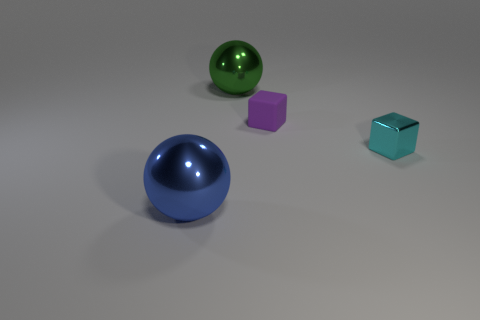Add 3 tiny gray blocks. How many objects exist? 7 Subtract all blue spheres. How many spheres are left? 1 Subtract all yellow cylinders. How many green balls are left? 1 Subtract 1 balls. How many balls are left? 1 Subtract all purple balls. Subtract all brown cubes. How many balls are left? 2 Subtract all cyan things. Subtract all large things. How many objects are left? 1 Add 4 big green metallic objects. How many big green metallic objects are left? 5 Add 3 tiny shiny things. How many tiny shiny things exist? 4 Subtract 0 gray cylinders. How many objects are left? 4 